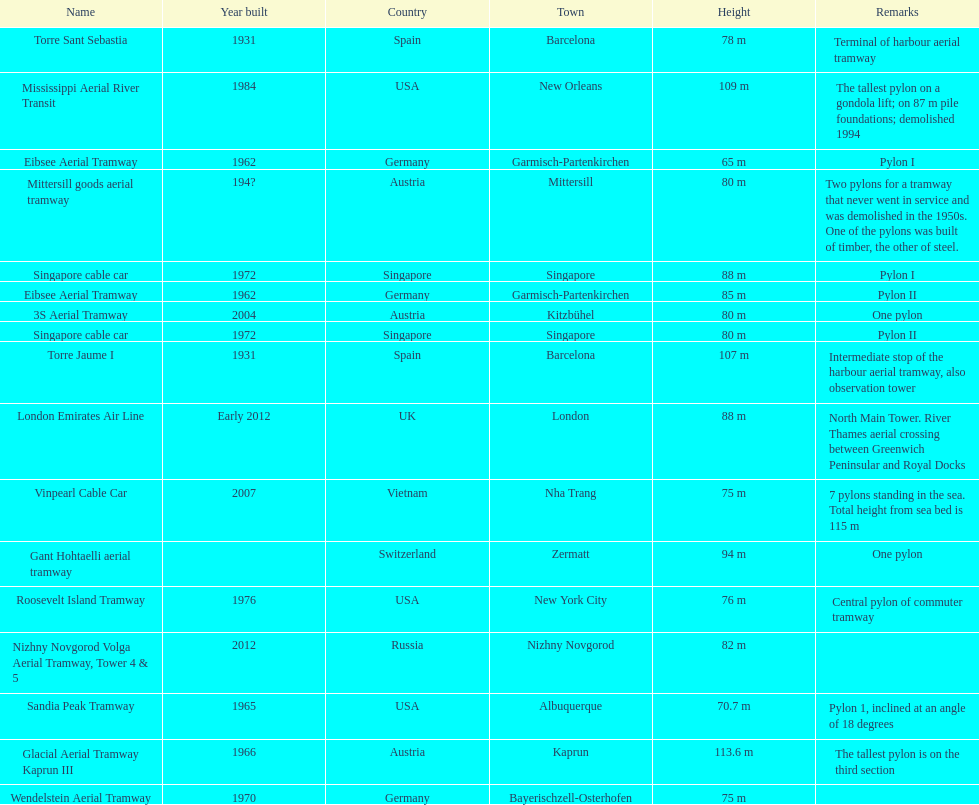How many pylons can be found in austria? 3. 